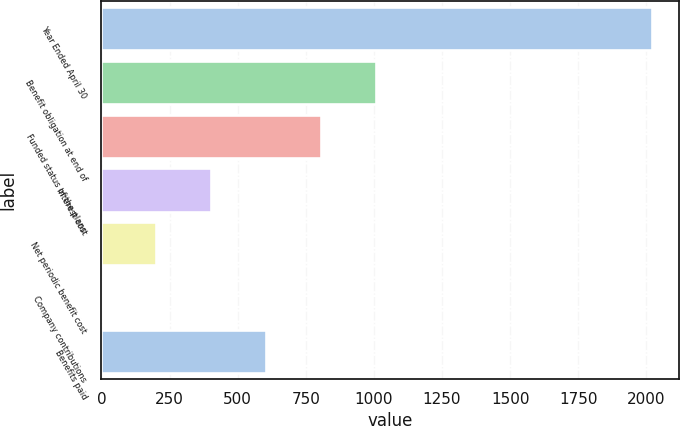<chart> <loc_0><loc_0><loc_500><loc_500><bar_chart><fcel>Year Ended April 30<fcel>Benefit obligation at end of<fcel>Funded status of the plans<fcel>Interest cost<fcel>Net periodic benefit cost<fcel>Company contributions<fcel>Benefits paid<nl><fcel>2019<fcel>1009.55<fcel>807.66<fcel>403.88<fcel>201.99<fcel>0.1<fcel>605.77<nl></chart> 